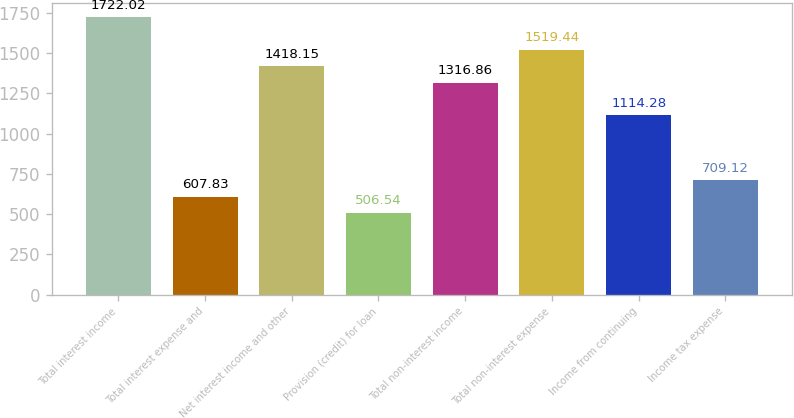<chart> <loc_0><loc_0><loc_500><loc_500><bar_chart><fcel>Total interest income<fcel>Total interest expense and<fcel>Net interest income and other<fcel>Provision (credit) for loan<fcel>Total non-interest income<fcel>Total non-interest expense<fcel>Income from continuing<fcel>Income tax expense<nl><fcel>1722.02<fcel>607.83<fcel>1418.15<fcel>506.54<fcel>1316.86<fcel>1519.44<fcel>1114.28<fcel>709.12<nl></chart> 